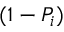Convert formula to latex. <formula><loc_0><loc_0><loc_500><loc_500>( 1 - P _ { i } )</formula> 